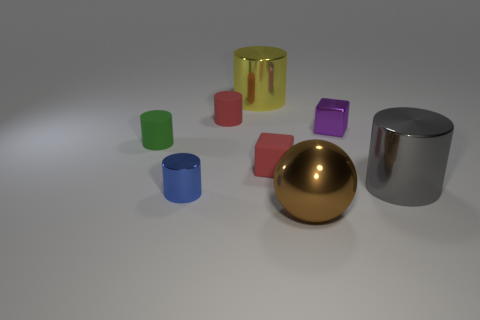Subtract 1 cylinders. How many cylinders are left? 4 Subtract all blue cylinders. How many cylinders are left? 4 Subtract all gray metal cylinders. How many cylinders are left? 4 Subtract all green cylinders. Subtract all yellow balls. How many cylinders are left? 4 Add 1 brown metal balls. How many objects exist? 9 Subtract all cylinders. How many objects are left? 3 Add 4 brown shiny spheres. How many brown shiny spheres are left? 5 Add 4 small purple shiny cubes. How many small purple shiny cubes exist? 5 Subtract 0 purple cylinders. How many objects are left? 8 Subtract all red rubber cylinders. Subtract all tiny green rubber cylinders. How many objects are left? 6 